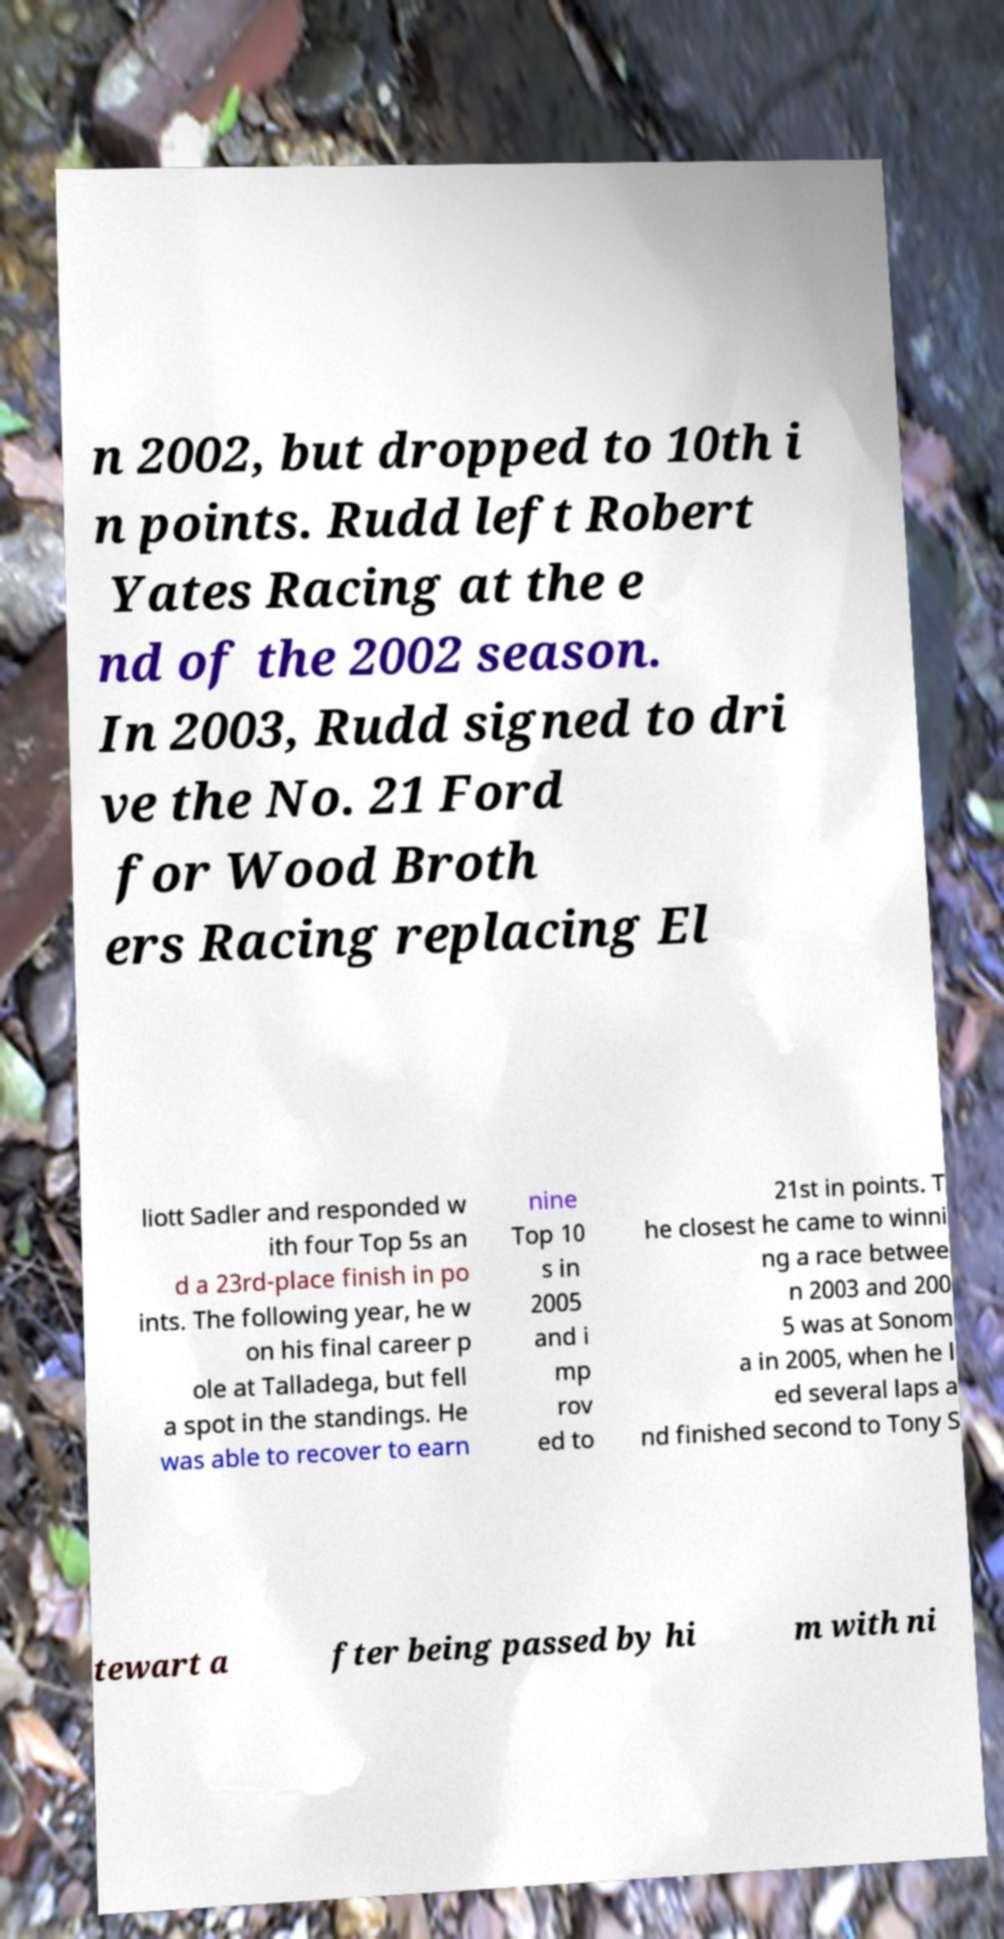For documentation purposes, I need the text within this image transcribed. Could you provide that? n 2002, but dropped to 10th i n points. Rudd left Robert Yates Racing at the e nd of the 2002 season. In 2003, Rudd signed to dri ve the No. 21 Ford for Wood Broth ers Racing replacing El liott Sadler and responded w ith four Top 5s an d a 23rd-place finish in po ints. The following year, he w on his final career p ole at Talladega, but fell a spot in the standings. He was able to recover to earn nine Top 10 s in 2005 and i mp rov ed to 21st in points. T he closest he came to winni ng a race betwee n 2003 and 200 5 was at Sonom a in 2005, when he l ed several laps a nd finished second to Tony S tewart a fter being passed by hi m with ni 